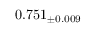Convert formula to latex. <formula><loc_0><loc_0><loc_500><loc_500>0 . 7 5 1 _ { \pm 0 . 0 0 9 }</formula> 